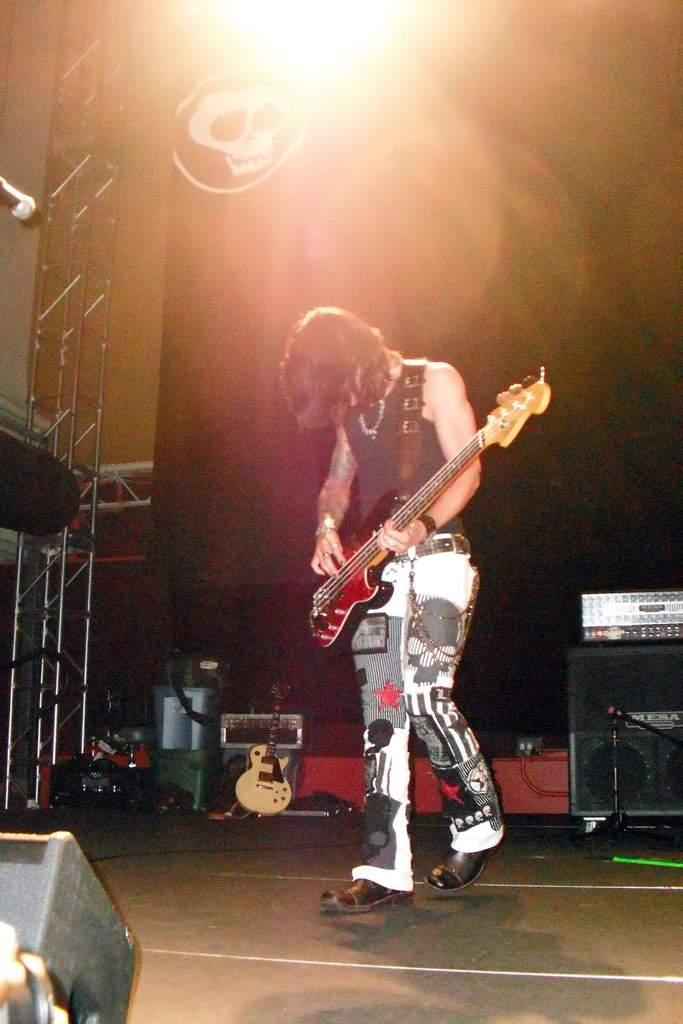Who is the main subject in the image? There is a man in the image. What is the man doing in the image? The man is playing a guitar. Where is the man located in the image? The man is on a dais. What is the man's posture in the image? The man is standing. What type of wound can be seen on the man's hand in the image? There is no wound visible on the man's hand in the image. What type of leather material is used to make the guitar in the image? The type of leather material used to make the guitar cannot be determined from the image. 